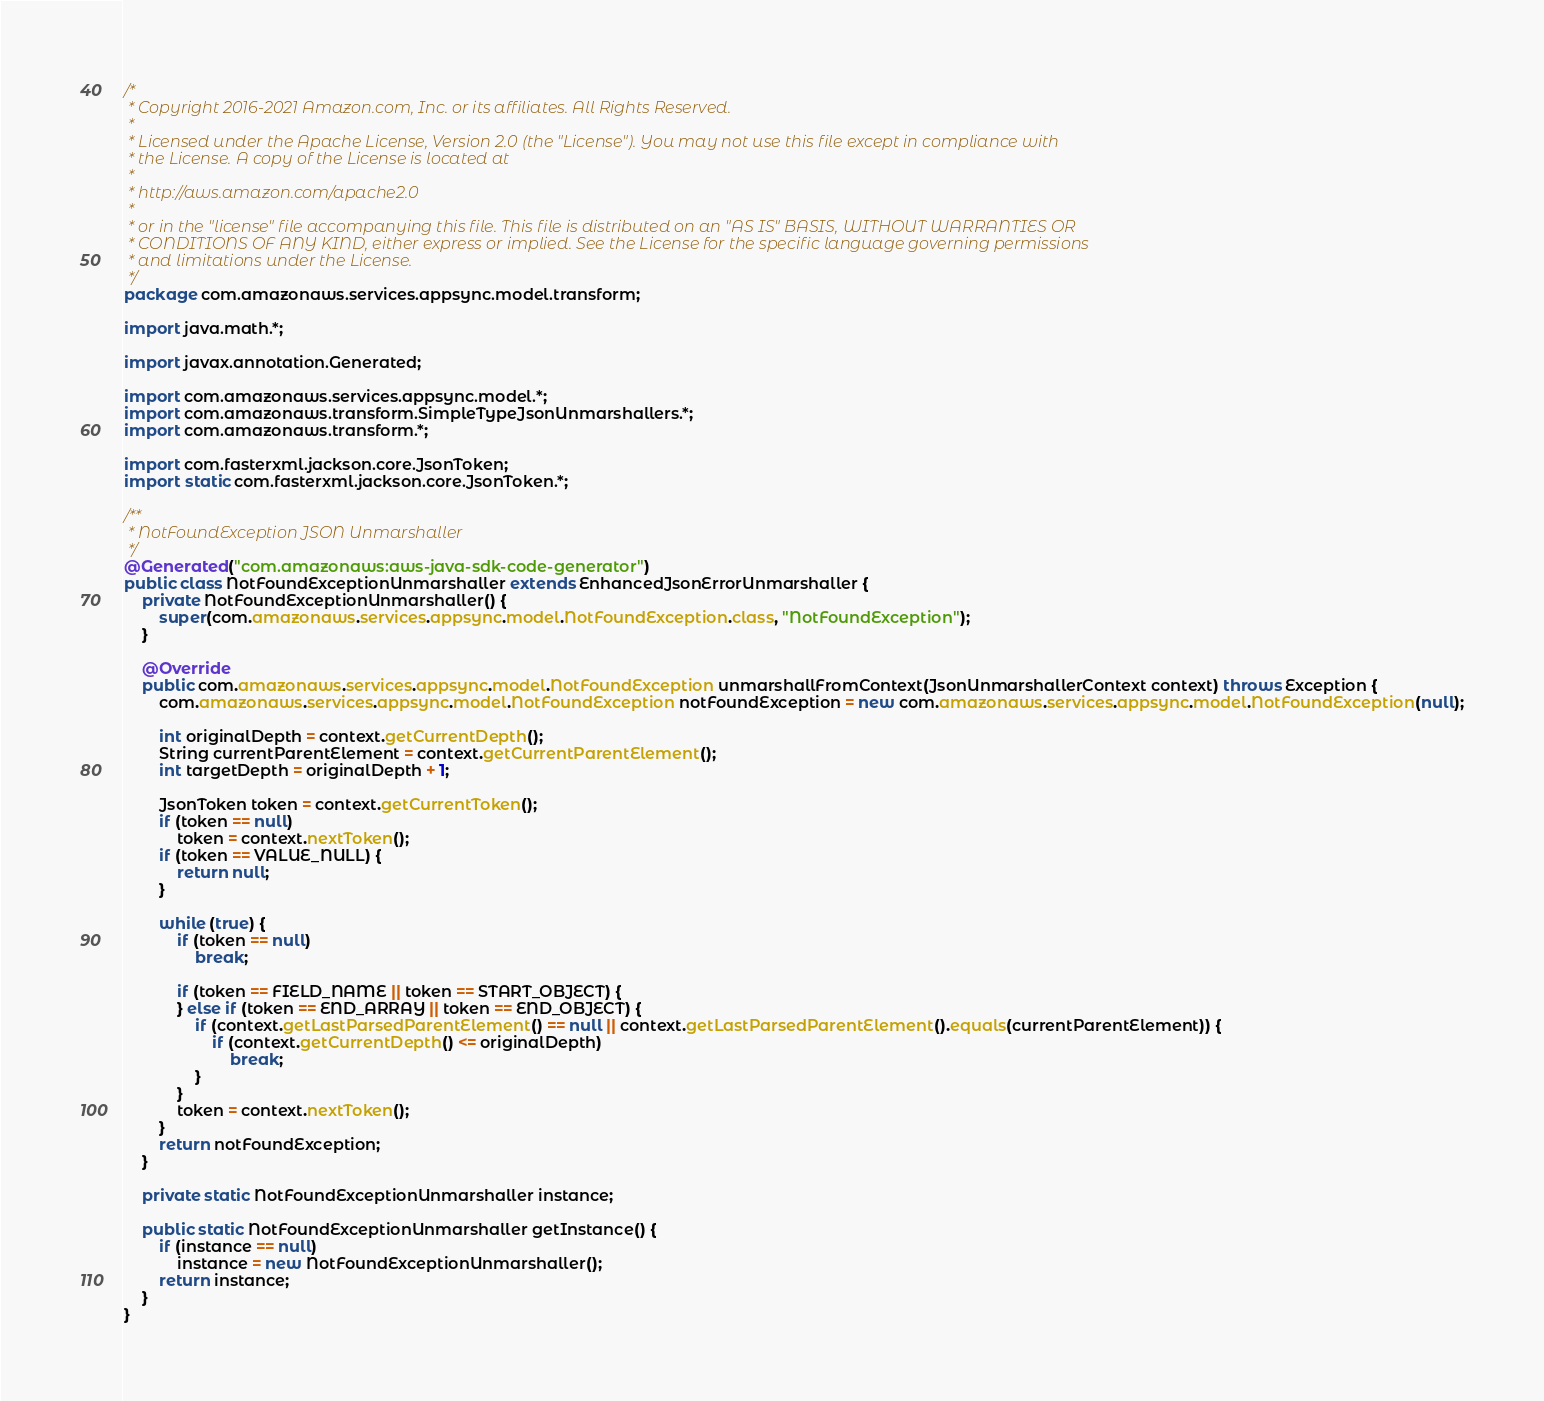Convert code to text. <code><loc_0><loc_0><loc_500><loc_500><_Java_>/*
 * Copyright 2016-2021 Amazon.com, Inc. or its affiliates. All Rights Reserved.
 * 
 * Licensed under the Apache License, Version 2.0 (the "License"). You may not use this file except in compliance with
 * the License. A copy of the License is located at
 * 
 * http://aws.amazon.com/apache2.0
 * 
 * or in the "license" file accompanying this file. This file is distributed on an "AS IS" BASIS, WITHOUT WARRANTIES OR
 * CONDITIONS OF ANY KIND, either express or implied. See the License for the specific language governing permissions
 * and limitations under the License.
 */
package com.amazonaws.services.appsync.model.transform;

import java.math.*;

import javax.annotation.Generated;

import com.amazonaws.services.appsync.model.*;
import com.amazonaws.transform.SimpleTypeJsonUnmarshallers.*;
import com.amazonaws.transform.*;

import com.fasterxml.jackson.core.JsonToken;
import static com.fasterxml.jackson.core.JsonToken.*;

/**
 * NotFoundException JSON Unmarshaller
 */
@Generated("com.amazonaws:aws-java-sdk-code-generator")
public class NotFoundExceptionUnmarshaller extends EnhancedJsonErrorUnmarshaller {
    private NotFoundExceptionUnmarshaller() {
        super(com.amazonaws.services.appsync.model.NotFoundException.class, "NotFoundException");
    }

    @Override
    public com.amazonaws.services.appsync.model.NotFoundException unmarshallFromContext(JsonUnmarshallerContext context) throws Exception {
        com.amazonaws.services.appsync.model.NotFoundException notFoundException = new com.amazonaws.services.appsync.model.NotFoundException(null);

        int originalDepth = context.getCurrentDepth();
        String currentParentElement = context.getCurrentParentElement();
        int targetDepth = originalDepth + 1;

        JsonToken token = context.getCurrentToken();
        if (token == null)
            token = context.nextToken();
        if (token == VALUE_NULL) {
            return null;
        }

        while (true) {
            if (token == null)
                break;

            if (token == FIELD_NAME || token == START_OBJECT) {
            } else if (token == END_ARRAY || token == END_OBJECT) {
                if (context.getLastParsedParentElement() == null || context.getLastParsedParentElement().equals(currentParentElement)) {
                    if (context.getCurrentDepth() <= originalDepth)
                        break;
                }
            }
            token = context.nextToken();
        }
        return notFoundException;
    }

    private static NotFoundExceptionUnmarshaller instance;

    public static NotFoundExceptionUnmarshaller getInstance() {
        if (instance == null)
            instance = new NotFoundExceptionUnmarshaller();
        return instance;
    }
}
</code> 